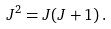Convert formula to latex. <formula><loc_0><loc_0><loc_500><loc_500>J ^ { 2 } = J ( J + 1 ) \, .</formula> 